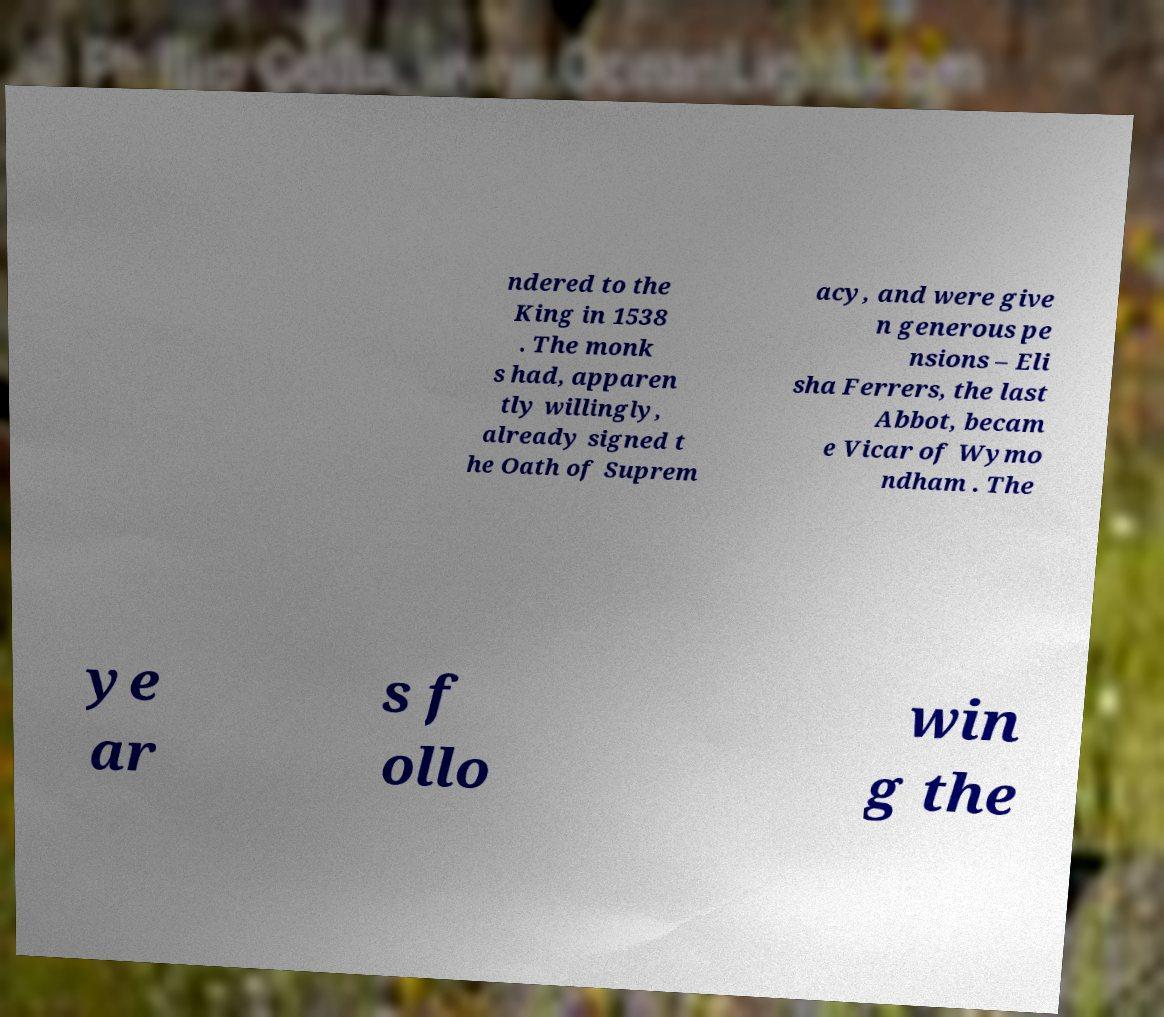Could you assist in decoding the text presented in this image and type it out clearly? ndered to the King in 1538 . The monk s had, apparen tly willingly, already signed t he Oath of Suprem acy, and were give n generous pe nsions – Eli sha Ferrers, the last Abbot, becam e Vicar of Wymo ndham . The ye ar s f ollo win g the 